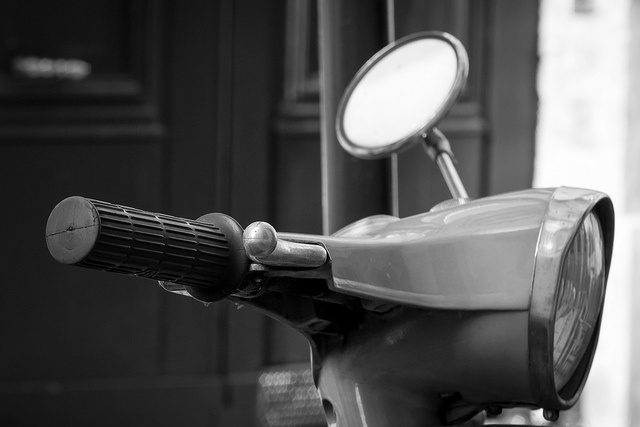Describe the objects in this image and their specific colors. I can see a motorcycle in black, gray, darkgray, and lightgray tones in this image. 